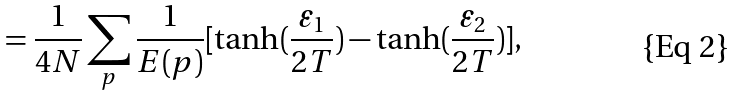<formula> <loc_0><loc_0><loc_500><loc_500>= \frac { 1 } { 4 N } \sum _ { p } \frac { 1 } { E ( { p } ) } [ \tanh ( \frac { \varepsilon _ { 1 } } { 2 T } ) - \tanh ( \frac { \varepsilon _ { 2 } } { 2 T } ) ] ,</formula> 